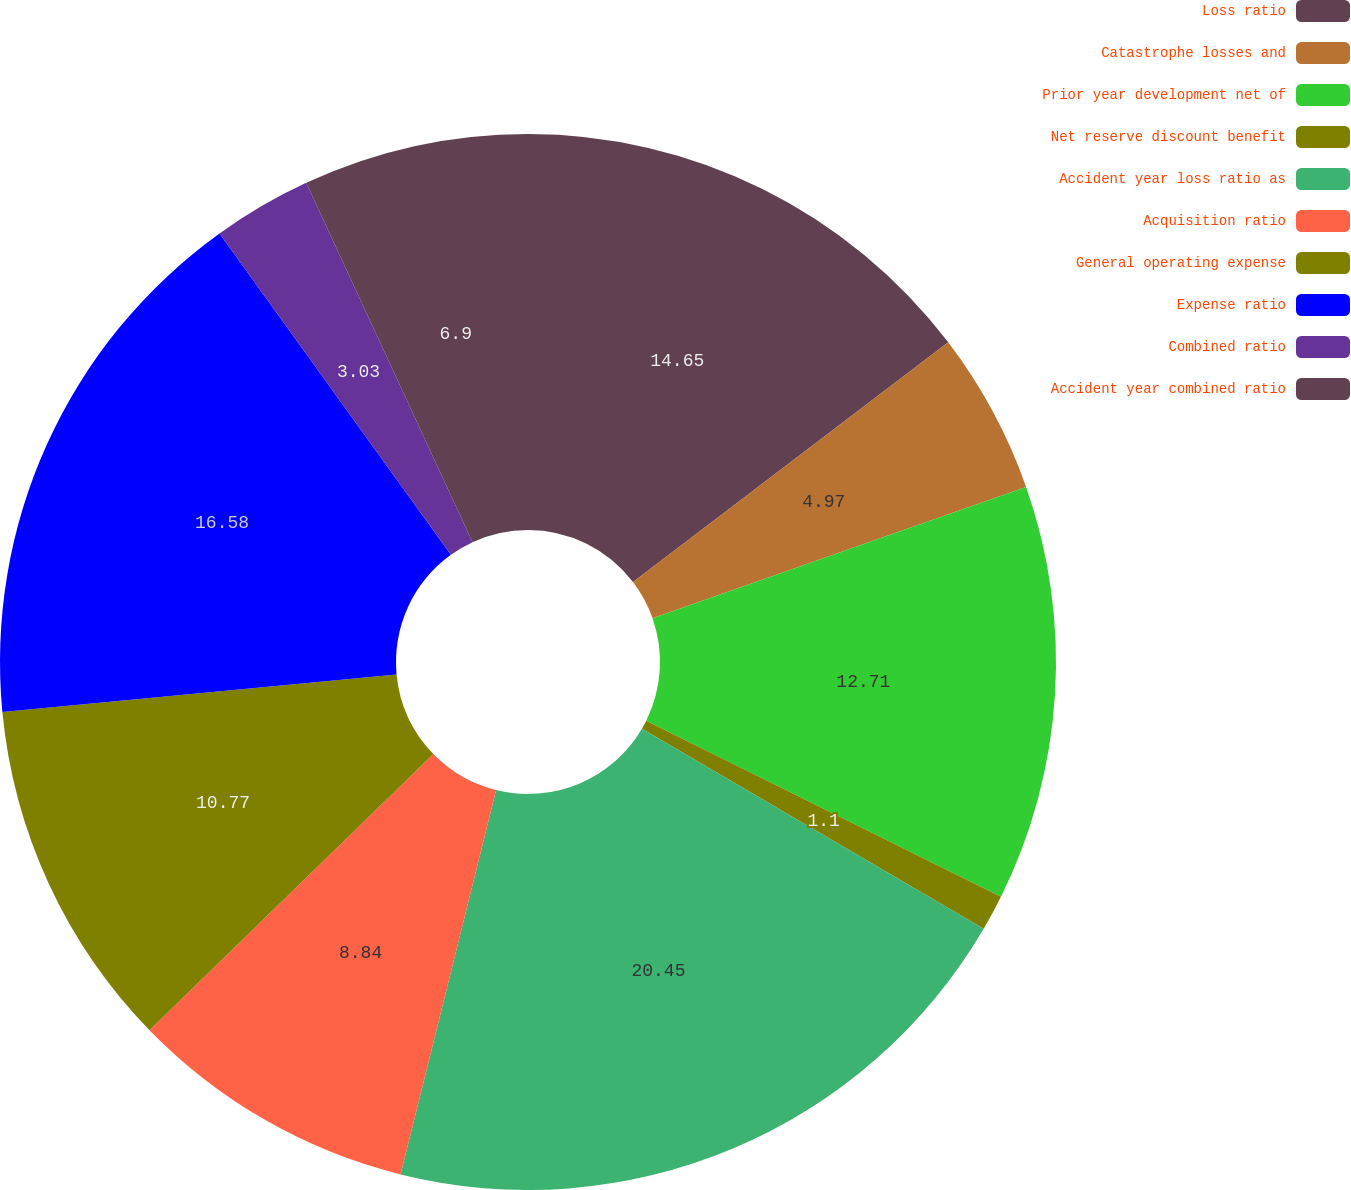Convert chart. <chart><loc_0><loc_0><loc_500><loc_500><pie_chart><fcel>Loss ratio<fcel>Catastrophe losses and<fcel>Prior year development net of<fcel>Net reserve discount benefit<fcel>Accident year loss ratio as<fcel>Acquisition ratio<fcel>General operating expense<fcel>Expense ratio<fcel>Combined ratio<fcel>Accident year combined ratio<nl><fcel>14.65%<fcel>4.97%<fcel>12.71%<fcel>1.1%<fcel>20.45%<fcel>8.84%<fcel>10.77%<fcel>16.58%<fcel>3.03%<fcel>6.9%<nl></chart> 